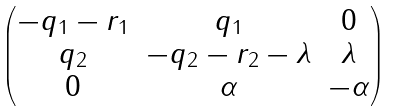<formula> <loc_0><loc_0><loc_500><loc_500>\begin{pmatrix} - q _ { 1 } - r _ { 1 } & q _ { 1 } & 0 \\ q _ { 2 } & - q _ { 2 } - r _ { 2 } - \lambda & \lambda \\ 0 & \alpha & - \alpha \end{pmatrix}</formula> 